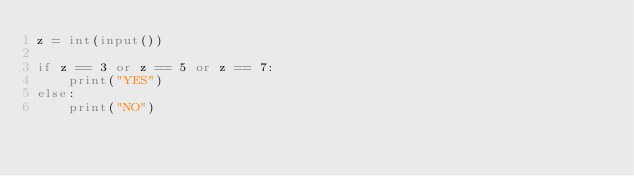Convert code to text. <code><loc_0><loc_0><loc_500><loc_500><_Python_>z = int(input())

if z == 3 or z == 5 or z == 7:
    print("YES")
else:
    print("NO")</code> 